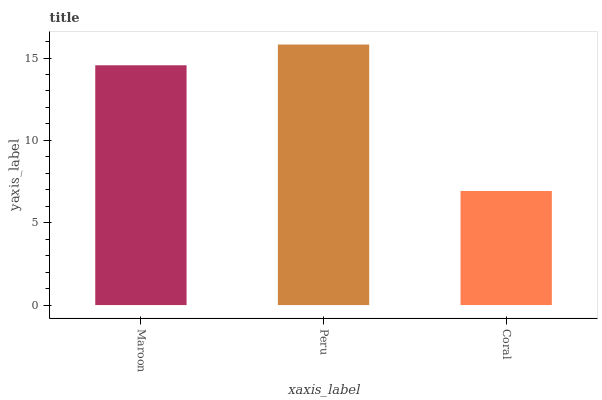Is Coral the minimum?
Answer yes or no. Yes. Is Peru the maximum?
Answer yes or no. Yes. Is Peru the minimum?
Answer yes or no. No. Is Coral the maximum?
Answer yes or no. No. Is Peru greater than Coral?
Answer yes or no. Yes. Is Coral less than Peru?
Answer yes or no. Yes. Is Coral greater than Peru?
Answer yes or no. No. Is Peru less than Coral?
Answer yes or no. No. Is Maroon the high median?
Answer yes or no. Yes. Is Maroon the low median?
Answer yes or no. Yes. Is Peru the high median?
Answer yes or no. No. Is Coral the low median?
Answer yes or no. No. 